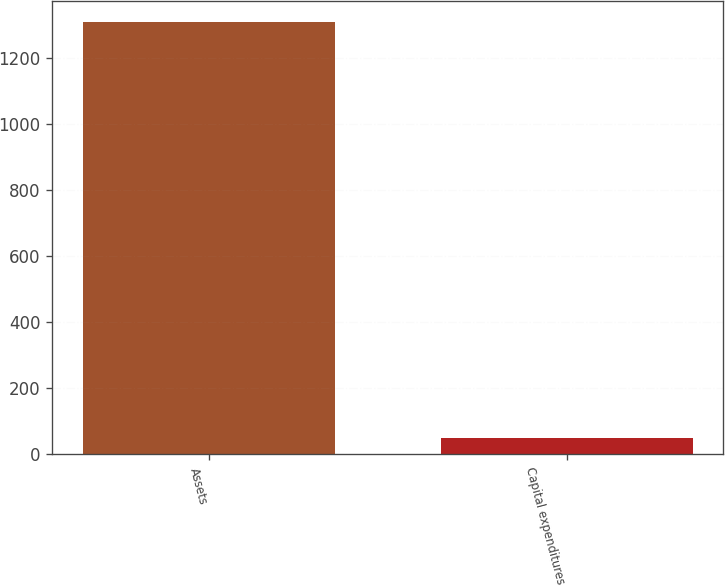<chart> <loc_0><loc_0><loc_500><loc_500><bar_chart><fcel>Assets<fcel>Capital expenditures<nl><fcel>1307<fcel>51<nl></chart> 